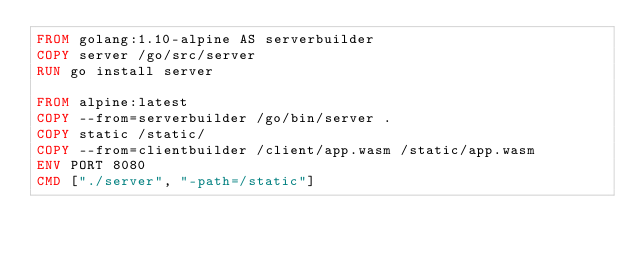Convert code to text. <code><loc_0><loc_0><loc_500><loc_500><_Dockerfile_>FROM golang:1.10-alpine AS serverbuilder
COPY server /go/src/server
RUN go install server

FROM alpine:latest
COPY --from=serverbuilder /go/bin/server .
COPY static /static/
COPY --from=clientbuilder /client/app.wasm /static/app.wasm
ENV PORT 8080
CMD ["./server", "-path=/static"]
</code> 